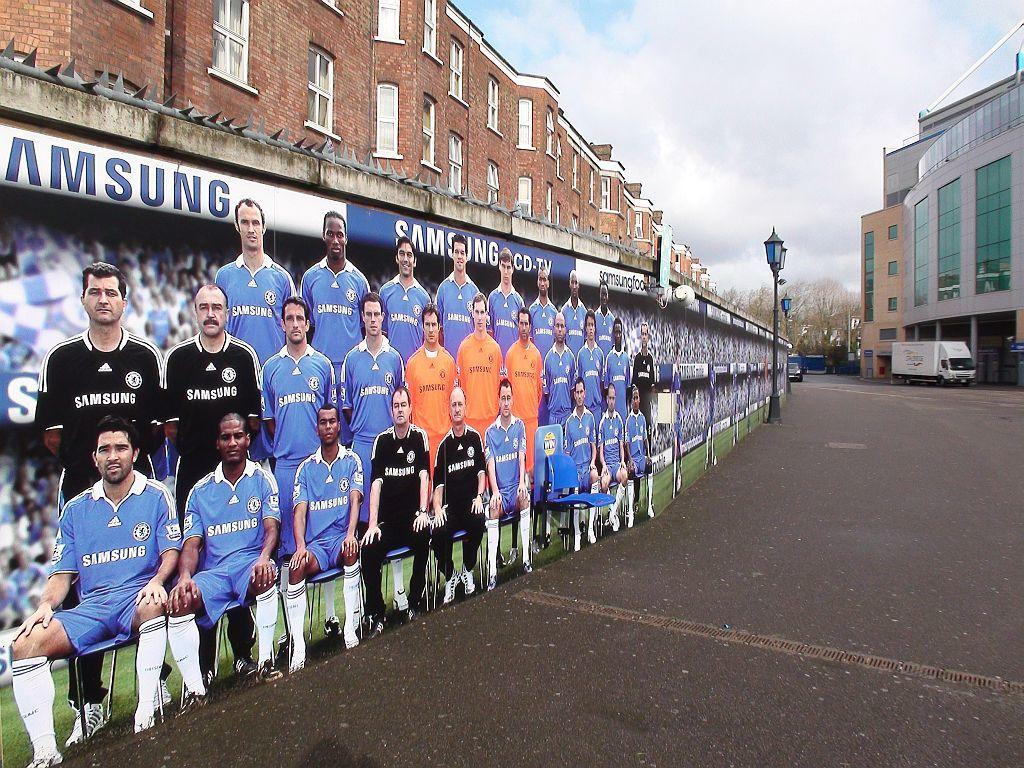<image>
Render a clear and concise summary of the photo. A large group of cardboard people wearing Samsung apparel. 